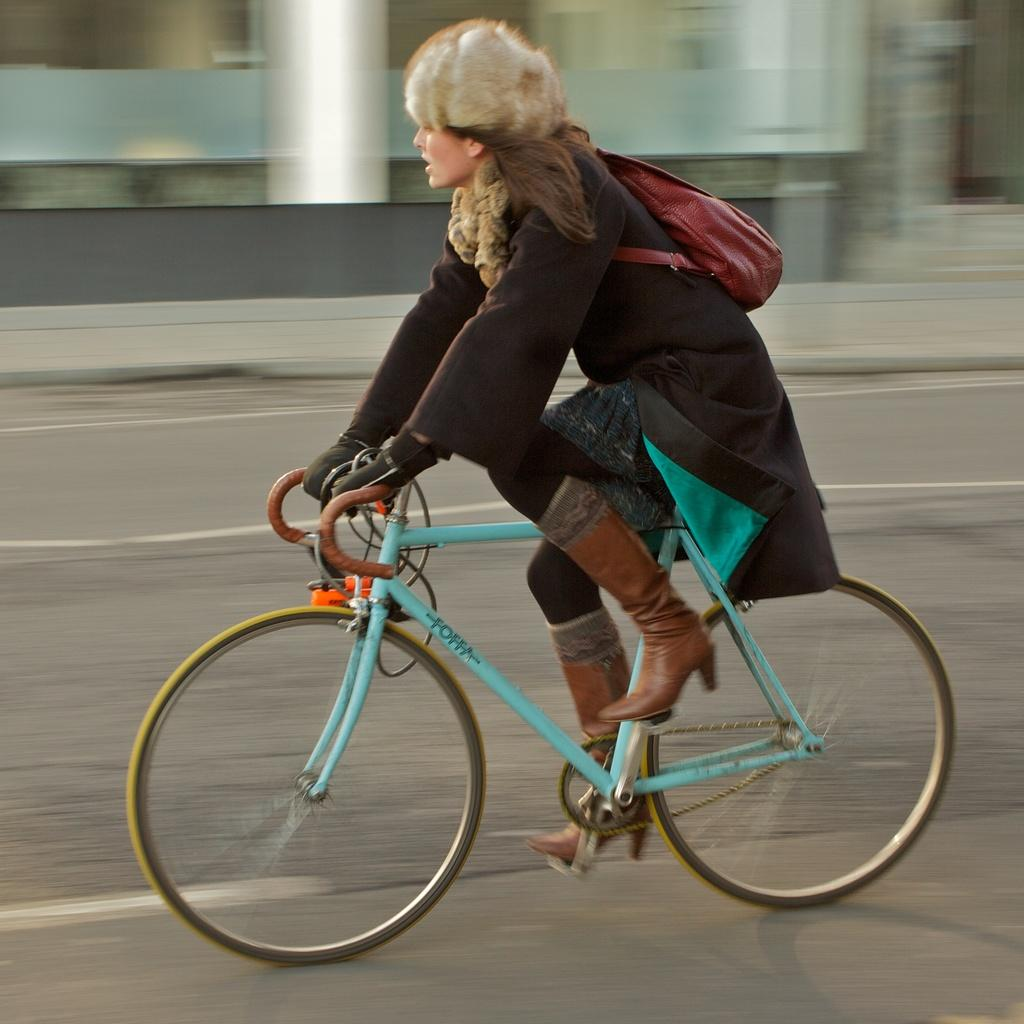Who is the main subject in the image? There is a woman in the image. What is the woman doing in the image? The woman is riding a bicycle. Where is the woman located in the image? The woman is on a road. What is the woman carrying on her back? The woman is wearing a backpack. What is the woman wearing on her upper body? The woman is wearing a black coat. What can be seen in the background of the image? There is a building in the background of the image. What type of pain is the woman experiencing while riding the bicycle in the image? There is no indication in the image that the woman is experiencing any pain. 